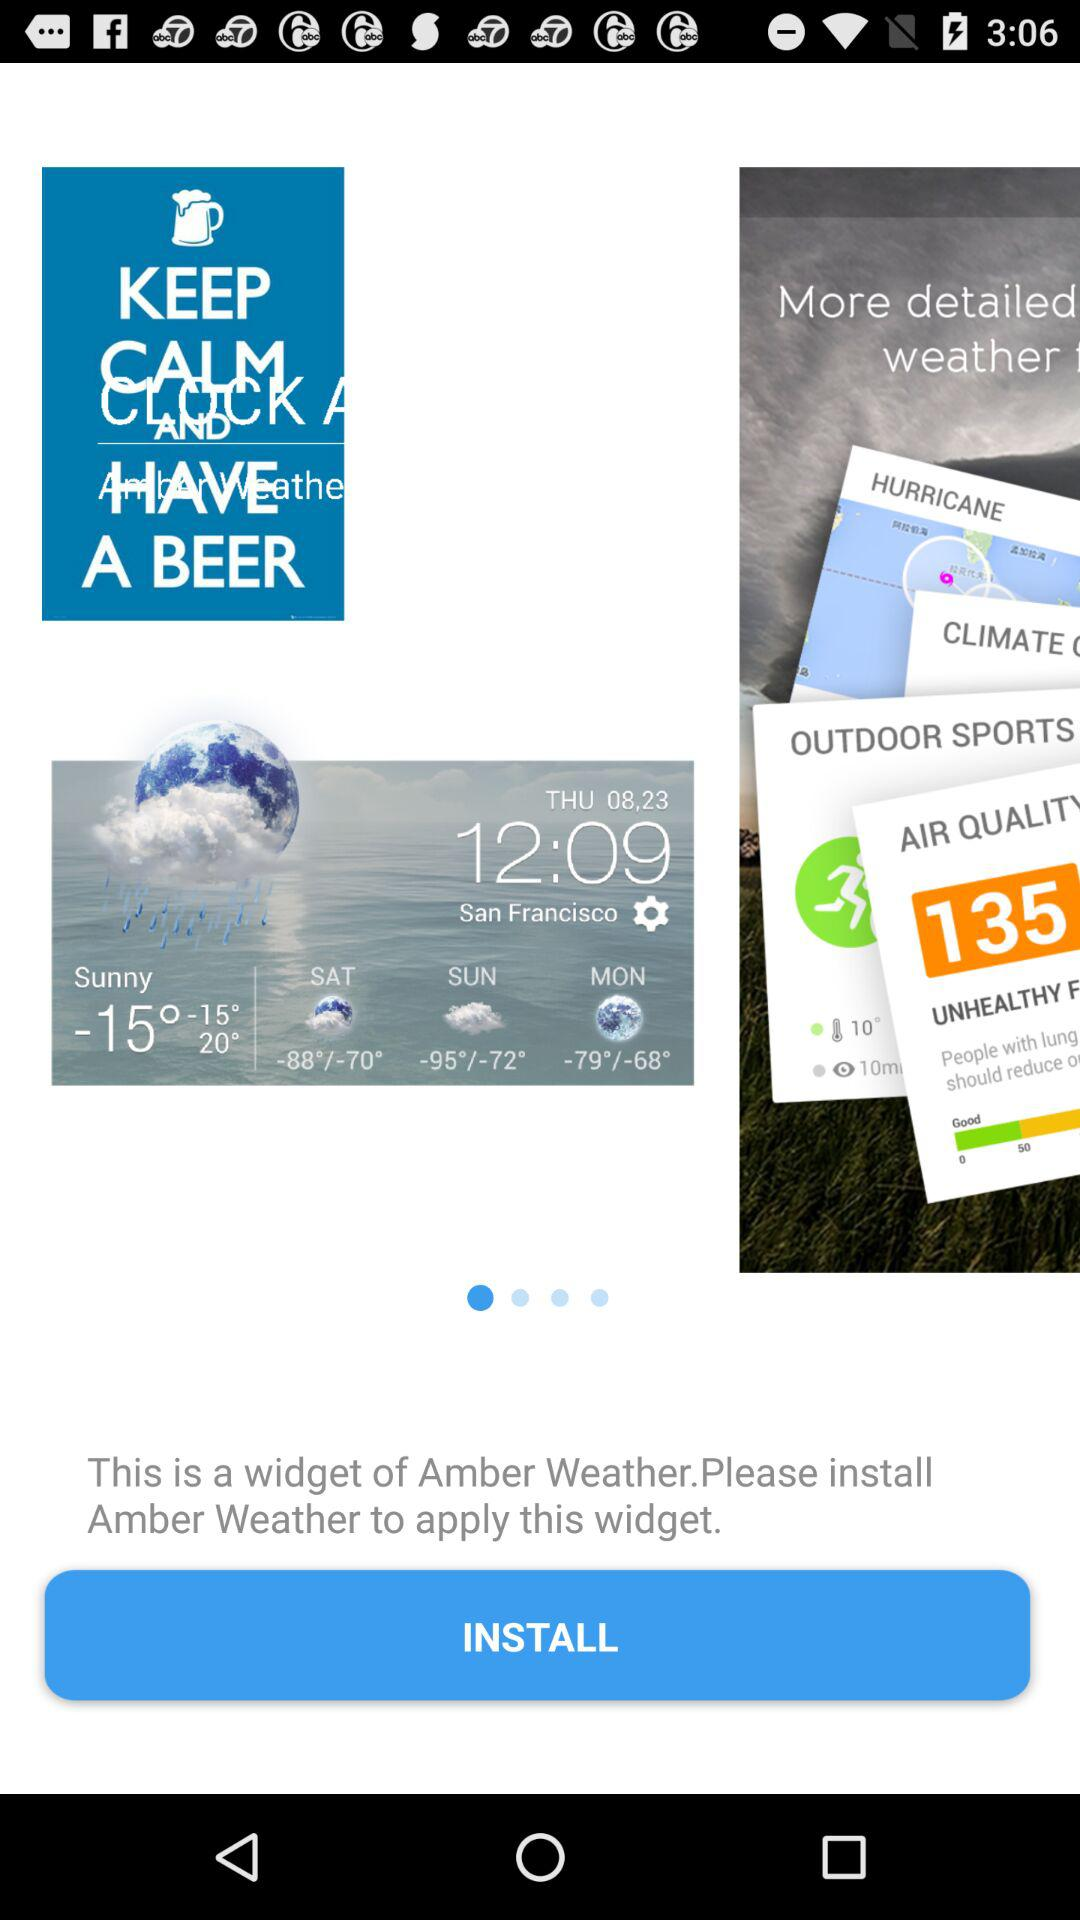What is the date displayed on the screen? The date is Thursday, August 23. 